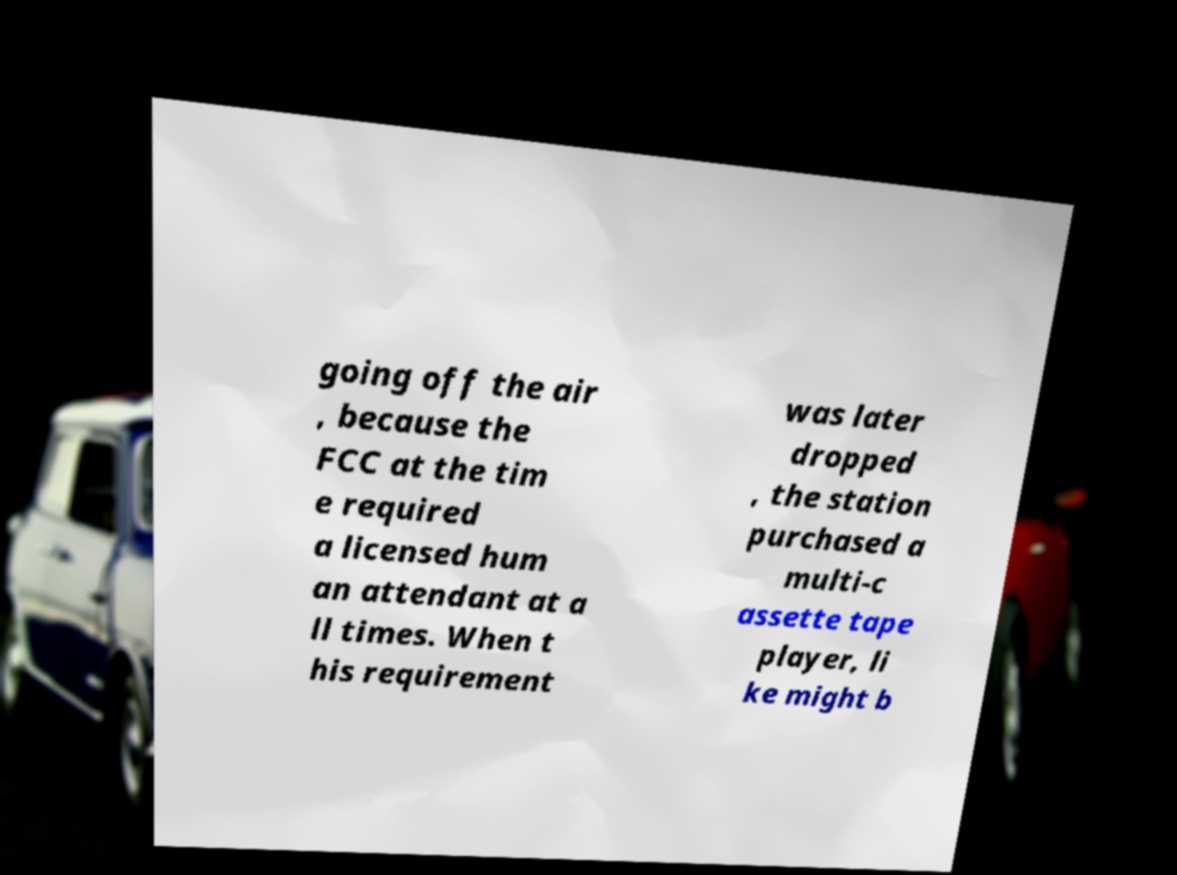What messages or text are displayed in this image? I need them in a readable, typed format. going off the air , because the FCC at the tim e required a licensed hum an attendant at a ll times. When t his requirement was later dropped , the station purchased a multi-c assette tape player, li ke might b 